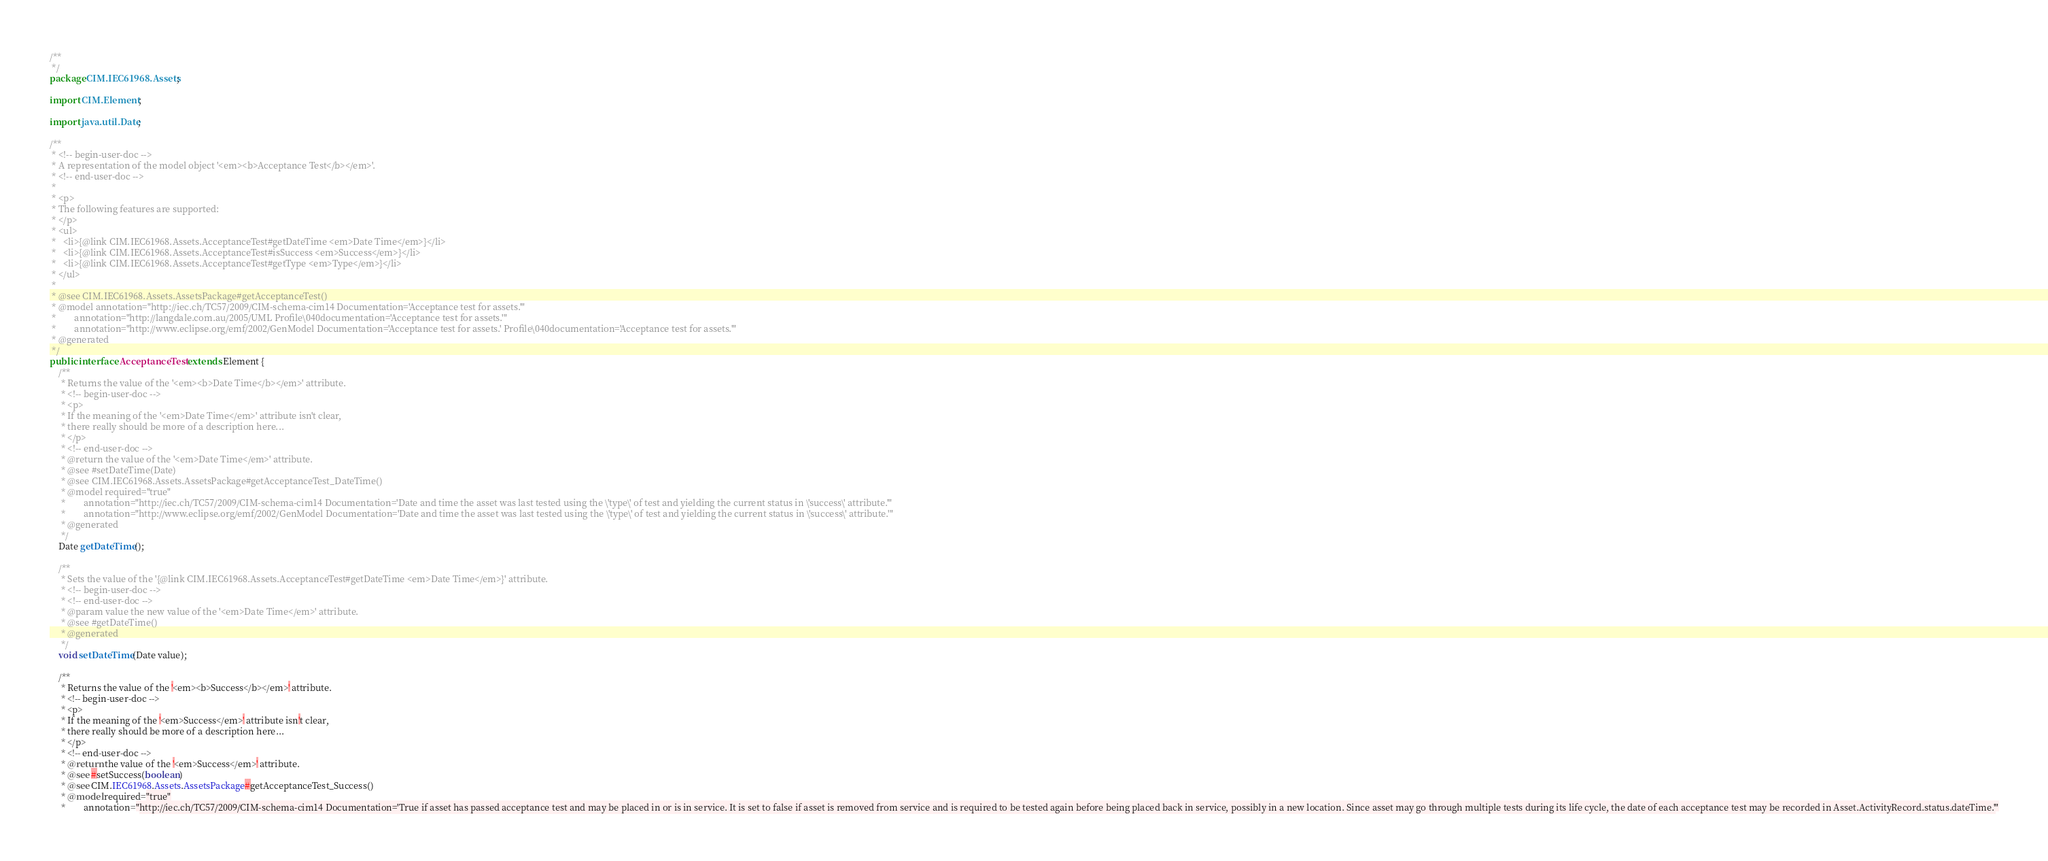Convert code to text. <code><loc_0><loc_0><loc_500><loc_500><_Java_>/**
 */
package CIM.IEC61968.Assets;

import CIM.Element;

import java.util.Date;

/**
 * <!-- begin-user-doc -->
 * A representation of the model object '<em><b>Acceptance Test</b></em>'.
 * <!-- end-user-doc -->
 *
 * <p>
 * The following features are supported:
 * </p>
 * <ul>
 *   <li>{@link CIM.IEC61968.Assets.AcceptanceTest#getDateTime <em>Date Time</em>}</li>
 *   <li>{@link CIM.IEC61968.Assets.AcceptanceTest#isSuccess <em>Success</em>}</li>
 *   <li>{@link CIM.IEC61968.Assets.AcceptanceTest#getType <em>Type</em>}</li>
 * </ul>
 *
 * @see CIM.IEC61968.Assets.AssetsPackage#getAcceptanceTest()
 * @model annotation="http://iec.ch/TC57/2009/CIM-schema-cim14 Documentation='Acceptance test for assets.'"
 *        annotation="http://langdale.com.au/2005/UML Profile\040documentation='Acceptance test for assets.'"
 *        annotation="http://www.eclipse.org/emf/2002/GenModel Documentation='Acceptance test for assets.' Profile\040documentation='Acceptance test for assets.'"
 * @generated
 */
public interface AcceptanceTest extends Element {
	/**
	 * Returns the value of the '<em><b>Date Time</b></em>' attribute.
	 * <!-- begin-user-doc -->
	 * <p>
	 * If the meaning of the '<em>Date Time</em>' attribute isn't clear,
	 * there really should be more of a description here...
	 * </p>
	 * <!-- end-user-doc -->
	 * @return the value of the '<em>Date Time</em>' attribute.
	 * @see #setDateTime(Date)
	 * @see CIM.IEC61968.Assets.AssetsPackage#getAcceptanceTest_DateTime()
	 * @model required="true"
	 *        annotation="http://iec.ch/TC57/2009/CIM-schema-cim14 Documentation='Date and time the asset was last tested using the \'type\' of test and yielding the current status in \'success\' attribute.'"
	 *        annotation="http://www.eclipse.org/emf/2002/GenModel Documentation='Date and time the asset was last tested using the \'type\' of test and yielding the current status in \'success\' attribute.'"
	 * @generated
	 */
	Date getDateTime();

	/**
	 * Sets the value of the '{@link CIM.IEC61968.Assets.AcceptanceTest#getDateTime <em>Date Time</em>}' attribute.
	 * <!-- begin-user-doc -->
	 * <!-- end-user-doc -->
	 * @param value the new value of the '<em>Date Time</em>' attribute.
	 * @see #getDateTime()
	 * @generated
	 */
	void setDateTime(Date value);

	/**
	 * Returns the value of the '<em><b>Success</b></em>' attribute.
	 * <!-- begin-user-doc -->
	 * <p>
	 * If the meaning of the '<em>Success</em>' attribute isn't clear,
	 * there really should be more of a description here...
	 * </p>
	 * <!-- end-user-doc -->
	 * @return the value of the '<em>Success</em>' attribute.
	 * @see #setSuccess(boolean)
	 * @see CIM.IEC61968.Assets.AssetsPackage#getAcceptanceTest_Success()
	 * @model required="true"
	 *        annotation="http://iec.ch/TC57/2009/CIM-schema-cim14 Documentation='True if asset has passed acceptance test and may be placed in or is in service. It is set to false if asset is removed from service and is required to be tested again before being placed back in service, possibly in a new location. Since asset may go through multiple tests during its life cycle, the date of each acceptance test may be recorded in Asset.ActivityRecord.status.dateTime.'"</code> 